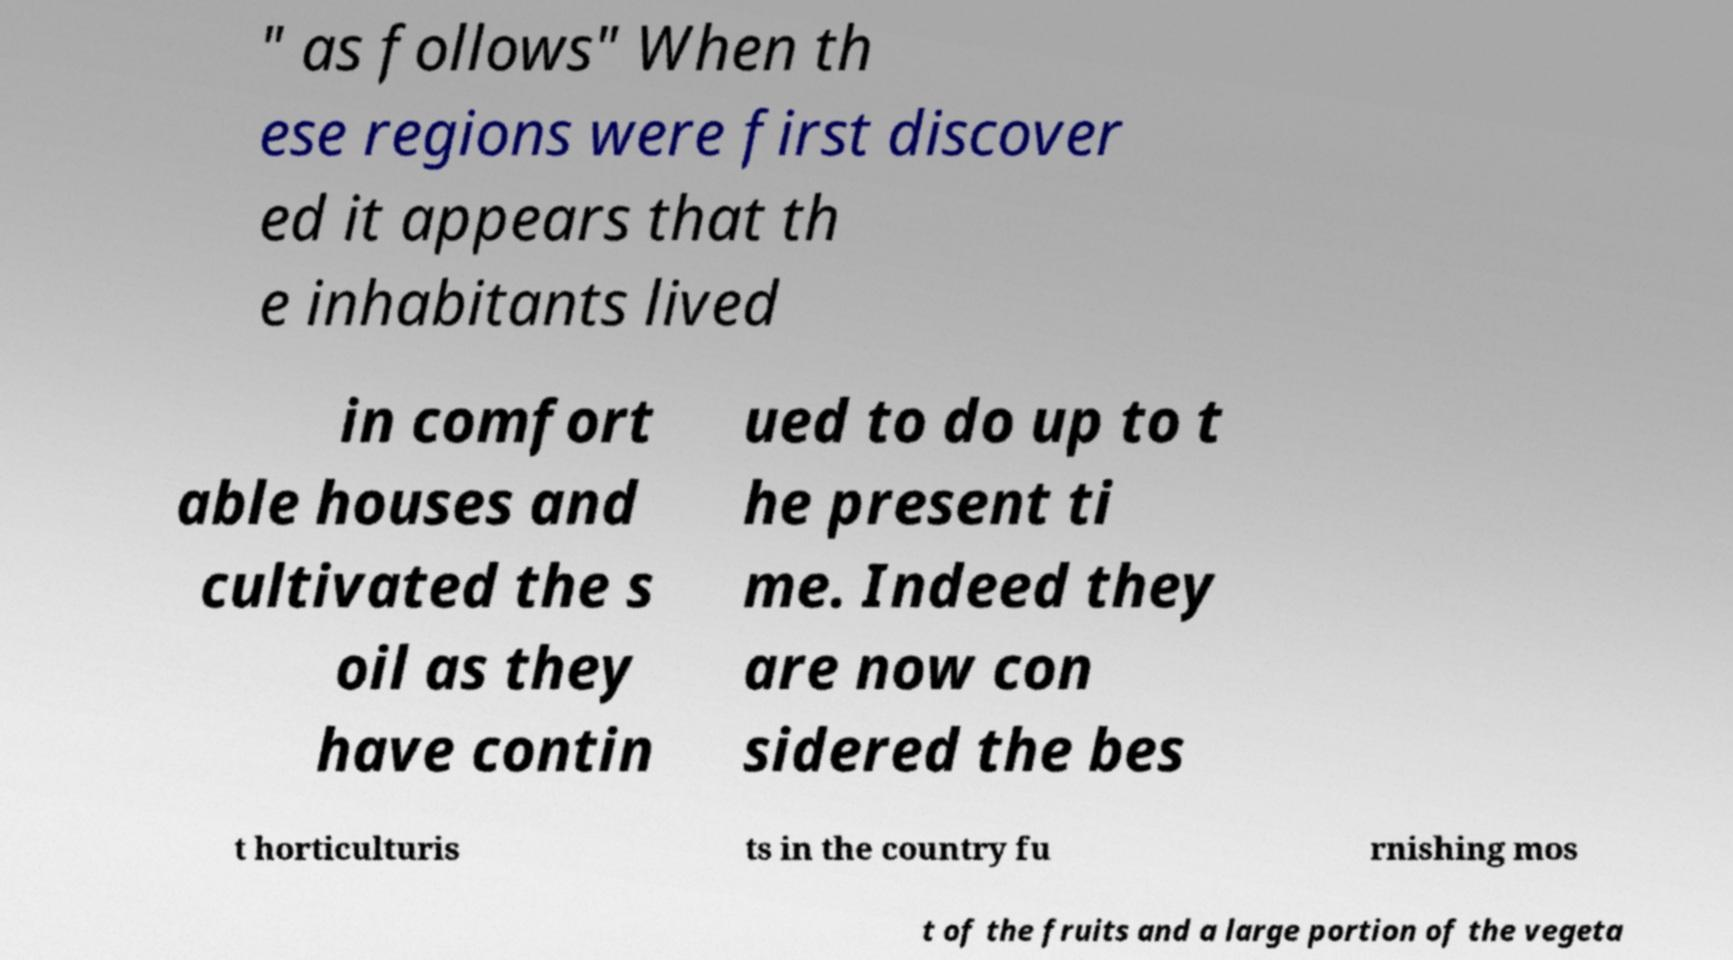I need the written content from this picture converted into text. Can you do that? " as follows" When th ese regions were first discover ed it appears that th e inhabitants lived in comfort able houses and cultivated the s oil as they have contin ued to do up to t he present ti me. Indeed they are now con sidered the bes t horticulturis ts in the country fu rnishing mos t of the fruits and a large portion of the vegeta 